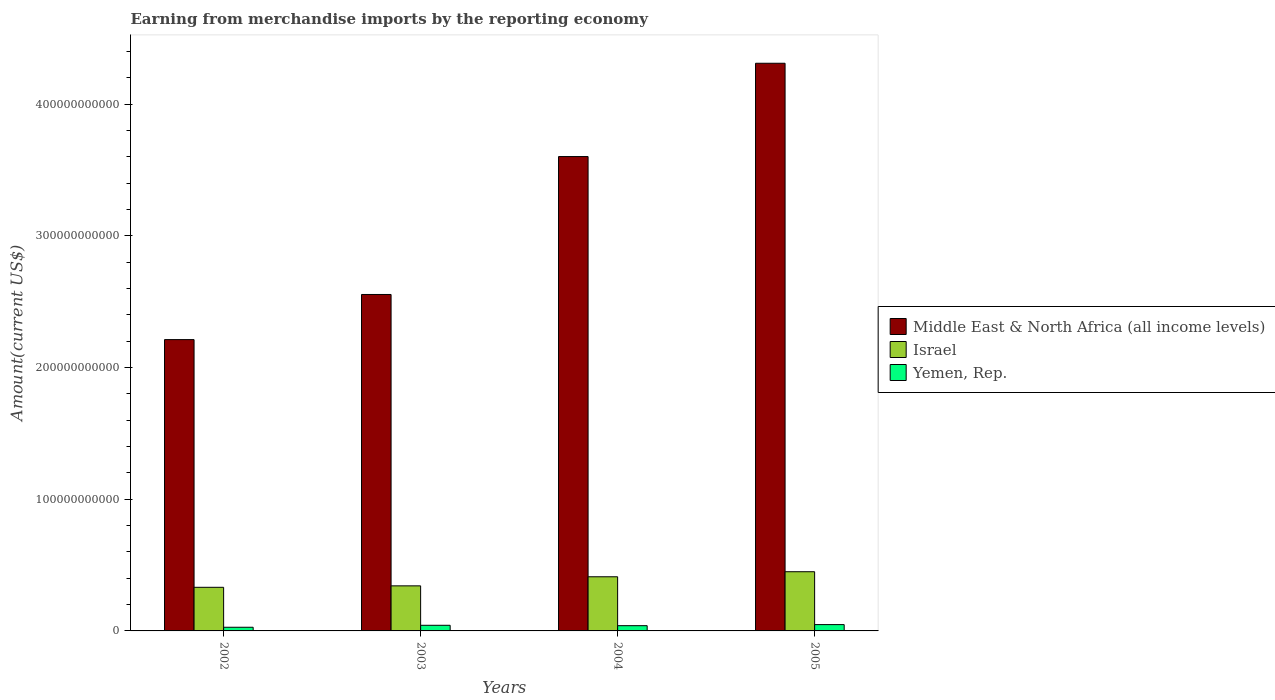Are the number of bars on each tick of the X-axis equal?
Ensure brevity in your answer.  Yes. How many bars are there on the 2nd tick from the left?
Provide a short and direct response. 3. What is the label of the 4th group of bars from the left?
Provide a short and direct response. 2005. What is the amount earned from merchandise imports in Middle East & North Africa (all income levels) in 2002?
Your answer should be very brief. 2.21e+11. Across all years, what is the maximum amount earned from merchandise imports in Middle East & North Africa (all income levels)?
Provide a short and direct response. 4.31e+11. Across all years, what is the minimum amount earned from merchandise imports in Middle East & North Africa (all income levels)?
Offer a terse response. 2.21e+11. In which year was the amount earned from merchandise imports in Israel maximum?
Make the answer very short. 2005. What is the total amount earned from merchandise imports in Israel in the graph?
Offer a terse response. 1.53e+11. What is the difference between the amount earned from merchandise imports in Middle East & North Africa (all income levels) in 2004 and that in 2005?
Provide a short and direct response. -7.08e+1. What is the difference between the amount earned from merchandise imports in Middle East & North Africa (all income levels) in 2005 and the amount earned from merchandise imports in Yemen, Rep. in 2002?
Offer a very short reply. 4.28e+11. What is the average amount earned from merchandise imports in Middle East & North Africa (all income levels) per year?
Keep it short and to the point. 3.17e+11. In the year 2002, what is the difference between the amount earned from merchandise imports in Yemen, Rep. and amount earned from merchandise imports in Middle East & North Africa (all income levels)?
Make the answer very short. -2.18e+11. In how many years, is the amount earned from merchandise imports in Israel greater than 80000000000 US$?
Your answer should be compact. 0. What is the ratio of the amount earned from merchandise imports in Middle East & North Africa (all income levels) in 2004 to that in 2005?
Your response must be concise. 0.84. Is the amount earned from merchandise imports in Yemen, Rep. in 2002 less than that in 2003?
Offer a terse response. Yes. What is the difference between the highest and the second highest amount earned from merchandise imports in Yemen, Rep.?
Give a very brief answer. 5.30e+08. What is the difference between the highest and the lowest amount earned from merchandise imports in Israel?
Provide a succinct answer. 1.18e+1. What does the 1st bar from the right in 2002 represents?
Make the answer very short. Yemen, Rep. How many years are there in the graph?
Give a very brief answer. 4. What is the difference between two consecutive major ticks on the Y-axis?
Offer a terse response. 1.00e+11. Are the values on the major ticks of Y-axis written in scientific E-notation?
Your answer should be very brief. No. Does the graph contain any zero values?
Your answer should be compact. No. Does the graph contain grids?
Offer a terse response. No. Where does the legend appear in the graph?
Ensure brevity in your answer.  Center right. How are the legend labels stacked?
Provide a short and direct response. Vertical. What is the title of the graph?
Your response must be concise. Earning from merchandise imports by the reporting economy. Does "Cote d'Ivoire" appear as one of the legend labels in the graph?
Offer a very short reply. No. What is the label or title of the Y-axis?
Make the answer very short. Amount(current US$). What is the Amount(current US$) in Middle East & North Africa (all income levels) in 2002?
Give a very brief answer. 2.21e+11. What is the Amount(current US$) in Israel in 2002?
Give a very brief answer. 3.31e+1. What is the Amount(current US$) of Yemen, Rep. in 2002?
Provide a succinct answer. 2.78e+09. What is the Amount(current US$) in Middle East & North Africa (all income levels) in 2003?
Give a very brief answer. 2.55e+11. What is the Amount(current US$) of Israel in 2003?
Offer a very short reply. 3.42e+1. What is the Amount(current US$) of Yemen, Rep. in 2003?
Give a very brief answer. 4.27e+09. What is the Amount(current US$) of Middle East & North Africa (all income levels) in 2004?
Your answer should be compact. 3.60e+11. What is the Amount(current US$) in Israel in 2004?
Your answer should be very brief. 4.11e+1. What is the Amount(current US$) in Yemen, Rep. in 2004?
Ensure brevity in your answer.  3.98e+09. What is the Amount(current US$) in Middle East & North Africa (all income levels) in 2005?
Offer a terse response. 4.31e+11. What is the Amount(current US$) in Israel in 2005?
Offer a terse response. 4.49e+1. What is the Amount(current US$) of Yemen, Rep. in 2005?
Your answer should be compact. 4.80e+09. Across all years, what is the maximum Amount(current US$) of Middle East & North Africa (all income levels)?
Ensure brevity in your answer.  4.31e+11. Across all years, what is the maximum Amount(current US$) in Israel?
Ensure brevity in your answer.  4.49e+1. Across all years, what is the maximum Amount(current US$) in Yemen, Rep.?
Provide a short and direct response. 4.80e+09. Across all years, what is the minimum Amount(current US$) of Middle East & North Africa (all income levels)?
Keep it short and to the point. 2.21e+11. Across all years, what is the minimum Amount(current US$) in Israel?
Your answer should be very brief. 3.31e+1. Across all years, what is the minimum Amount(current US$) in Yemen, Rep.?
Your response must be concise. 2.78e+09. What is the total Amount(current US$) in Middle East & North Africa (all income levels) in the graph?
Your answer should be very brief. 1.27e+12. What is the total Amount(current US$) of Israel in the graph?
Offer a very short reply. 1.53e+11. What is the total Amount(current US$) of Yemen, Rep. in the graph?
Make the answer very short. 1.58e+1. What is the difference between the Amount(current US$) of Middle East & North Africa (all income levels) in 2002 and that in 2003?
Give a very brief answer. -3.43e+1. What is the difference between the Amount(current US$) of Israel in 2002 and that in 2003?
Your answer should be compact. -1.11e+09. What is the difference between the Amount(current US$) of Yemen, Rep. in 2002 and that in 2003?
Ensure brevity in your answer.  -1.49e+09. What is the difference between the Amount(current US$) in Middle East & North Africa (all income levels) in 2002 and that in 2004?
Your response must be concise. -1.39e+11. What is the difference between the Amount(current US$) in Israel in 2002 and that in 2004?
Keep it short and to the point. -7.99e+09. What is the difference between the Amount(current US$) in Yemen, Rep. in 2002 and that in 2004?
Give a very brief answer. -1.21e+09. What is the difference between the Amount(current US$) in Middle East & North Africa (all income levels) in 2002 and that in 2005?
Ensure brevity in your answer.  -2.10e+11. What is the difference between the Amount(current US$) of Israel in 2002 and that in 2005?
Your answer should be compact. -1.18e+1. What is the difference between the Amount(current US$) in Yemen, Rep. in 2002 and that in 2005?
Your response must be concise. -2.02e+09. What is the difference between the Amount(current US$) in Middle East & North Africa (all income levels) in 2003 and that in 2004?
Your answer should be very brief. -1.05e+11. What is the difference between the Amount(current US$) in Israel in 2003 and that in 2004?
Your response must be concise. -6.89e+09. What is the difference between the Amount(current US$) of Yemen, Rep. in 2003 and that in 2004?
Keep it short and to the point. 2.85e+08. What is the difference between the Amount(current US$) in Middle East & North Africa (all income levels) in 2003 and that in 2005?
Your answer should be compact. -1.76e+11. What is the difference between the Amount(current US$) of Israel in 2003 and that in 2005?
Your response must be concise. -1.07e+1. What is the difference between the Amount(current US$) in Yemen, Rep. in 2003 and that in 2005?
Give a very brief answer. -5.30e+08. What is the difference between the Amount(current US$) in Middle East & North Africa (all income levels) in 2004 and that in 2005?
Your answer should be very brief. -7.08e+1. What is the difference between the Amount(current US$) in Israel in 2004 and that in 2005?
Your answer should be very brief. -3.84e+09. What is the difference between the Amount(current US$) of Yemen, Rep. in 2004 and that in 2005?
Make the answer very short. -8.15e+08. What is the difference between the Amount(current US$) in Middle East & North Africa (all income levels) in 2002 and the Amount(current US$) in Israel in 2003?
Your response must be concise. 1.87e+11. What is the difference between the Amount(current US$) of Middle East & North Africa (all income levels) in 2002 and the Amount(current US$) of Yemen, Rep. in 2003?
Give a very brief answer. 2.17e+11. What is the difference between the Amount(current US$) in Israel in 2002 and the Amount(current US$) in Yemen, Rep. in 2003?
Give a very brief answer. 2.88e+1. What is the difference between the Amount(current US$) in Middle East & North Africa (all income levels) in 2002 and the Amount(current US$) in Israel in 2004?
Offer a terse response. 1.80e+11. What is the difference between the Amount(current US$) in Middle East & North Africa (all income levels) in 2002 and the Amount(current US$) in Yemen, Rep. in 2004?
Your answer should be compact. 2.17e+11. What is the difference between the Amount(current US$) in Israel in 2002 and the Amount(current US$) in Yemen, Rep. in 2004?
Offer a very short reply. 2.91e+1. What is the difference between the Amount(current US$) in Middle East & North Africa (all income levels) in 2002 and the Amount(current US$) in Israel in 2005?
Ensure brevity in your answer.  1.76e+11. What is the difference between the Amount(current US$) of Middle East & North Africa (all income levels) in 2002 and the Amount(current US$) of Yemen, Rep. in 2005?
Provide a succinct answer. 2.16e+11. What is the difference between the Amount(current US$) in Israel in 2002 and the Amount(current US$) in Yemen, Rep. in 2005?
Your response must be concise. 2.83e+1. What is the difference between the Amount(current US$) in Middle East & North Africa (all income levels) in 2003 and the Amount(current US$) in Israel in 2004?
Ensure brevity in your answer.  2.14e+11. What is the difference between the Amount(current US$) of Middle East & North Africa (all income levels) in 2003 and the Amount(current US$) of Yemen, Rep. in 2004?
Your answer should be very brief. 2.51e+11. What is the difference between the Amount(current US$) in Israel in 2003 and the Amount(current US$) in Yemen, Rep. in 2004?
Your answer should be very brief. 3.02e+1. What is the difference between the Amount(current US$) of Middle East & North Africa (all income levels) in 2003 and the Amount(current US$) of Israel in 2005?
Provide a short and direct response. 2.10e+11. What is the difference between the Amount(current US$) of Middle East & North Africa (all income levels) in 2003 and the Amount(current US$) of Yemen, Rep. in 2005?
Your answer should be very brief. 2.51e+11. What is the difference between the Amount(current US$) in Israel in 2003 and the Amount(current US$) in Yemen, Rep. in 2005?
Offer a very short reply. 2.94e+1. What is the difference between the Amount(current US$) of Middle East & North Africa (all income levels) in 2004 and the Amount(current US$) of Israel in 2005?
Provide a succinct answer. 3.15e+11. What is the difference between the Amount(current US$) in Middle East & North Africa (all income levels) in 2004 and the Amount(current US$) in Yemen, Rep. in 2005?
Your answer should be very brief. 3.55e+11. What is the difference between the Amount(current US$) in Israel in 2004 and the Amount(current US$) in Yemen, Rep. in 2005?
Provide a succinct answer. 3.63e+1. What is the average Amount(current US$) in Middle East & North Africa (all income levels) per year?
Give a very brief answer. 3.17e+11. What is the average Amount(current US$) in Israel per year?
Your answer should be very brief. 3.83e+1. What is the average Amount(current US$) of Yemen, Rep. per year?
Offer a terse response. 3.96e+09. In the year 2002, what is the difference between the Amount(current US$) of Middle East & North Africa (all income levels) and Amount(current US$) of Israel?
Provide a succinct answer. 1.88e+11. In the year 2002, what is the difference between the Amount(current US$) of Middle East & North Africa (all income levels) and Amount(current US$) of Yemen, Rep.?
Make the answer very short. 2.18e+11. In the year 2002, what is the difference between the Amount(current US$) in Israel and Amount(current US$) in Yemen, Rep.?
Provide a succinct answer. 3.03e+1. In the year 2003, what is the difference between the Amount(current US$) in Middle East & North Africa (all income levels) and Amount(current US$) in Israel?
Keep it short and to the point. 2.21e+11. In the year 2003, what is the difference between the Amount(current US$) of Middle East & North Africa (all income levels) and Amount(current US$) of Yemen, Rep.?
Ensure brevity in your answer.  2.51e+11. In the year 2003, what is the difference between the Amount(current US$) of Israel and Amount(current US$) of Yemen, Rep.?
Ensure brevity in your answer.  2.99e+1. In the year 2004, what is the difference between the Amount(current US$) in Middle East & North Africa (all income levels) and Amount(current US$) in Israel?
Make the answer very short. 3.19e+11. In the year 2004, what is the difference between the Amount(current US$) in Middle East & North Africa (all income levels) and Amount(current US$) in Yemen, Rep.?
Offer a terse response. 3.56e+11. In the year 2004, what is the difference between the Amount(current US$) of Israel and Amount(current US$) of Yemen, Rep.?
Offer a terse response. 3.71e+1. In the year 2005, what is the difference between the Amount(current US$) in Middle East & North Africa (all income levels) and Amount(current US$) in Israel?
Offer a very short reply. 3.86e+11. In the year 2005, what is the difference between the Amount(current US$) of Middle East & North Africa (all income levels) and Amount(current US$) of Yemen, Rep.?
Make the answer very short. 4.26e+11. In the year 2005, what is the difference between the Amount(current US$) of Israel and Amount(current US$) of Yemen, Rep.?
Make the answer very short. 4.01e+1. What is the ratio of the Amount(current US$) in Middle East & North Africa (all income levels) in 2002 to that in 2003?
Your response must be concise. 0.87. What is the ratio of the Amount(current US$) of Israel in 2002 to that in 2003?
Offer a terse response. 0.97. What is the ratio of the Amount(current US$) in Yemen, Rep. in 2002 to that in 2003?
Provide a succinct answer. 0.65. What is the ratio of the Amount(current US$) in Middle East & North Africa (all income levels) in 2002 to that in 2004?
Provide a succinct answer. 0.61. What is the ratio of the Amount(current US$) in Israel in 2002 to that in 2004?
Ensure brevity in your answer.  0.81. What is the ratio of the Amount(current US$) in Yemen, Rep. in 2002 to that in 2004?
Make the answer very short. 0.7. What is the ratio of the Amount(current US$) in Middle East & North Africa (all income levels) in 2002 to that in 2005?
Ensure brevity in your answer.  0.51. What is the ratio of the Amount(current US$) of Israel in 2002 to that in 2005?
Make the answer very short. 0.74. What is the ratio of the Amount(current US$) of Yemen, Rep. in 2002 to that in 2005?
Your answer should be very brief. 0.58. What is the ratio of the Amount(current US$) of Middle East & North Africa (all income levels) in 2003 to that in 2004?
Your answer should be compact. 0.71. What is the ratio of the Amount(current US$) in Israel in 2003 to that in 2004?
Your response must be concise. 0.83. What is the ratio of the Amount(current US$) of Yemen, Rep. in 2003 to that in 2004?
Offer a very short reply. 1.07. What is the ratio of the Amount(current US$) of Middle East & North Africa (all income levels) in 2003 to that in 2005?
Your answer should be compact. 0.59. What is the ratio of the Amount(current US$) in Israel in 2003 to that in 2005?
Make the answer very short. 0.76. What is the ratio of the Amount(current US$) in Yemen, Rep. in 2003 to that in 2005?
Give a very brief answer. 0.89. What is the ratio of the Amount(current US$) of Middle East & North Africa (all income levels) in 2004 to that in 2005?
Provide a short and direct response. 0.84. What is the ratio of the Amount(current US$) of Israel in 2004 to that in 2005?
Provide a short and direct response. 0.91. What is the ratio of the Amount(current US$) in Yemen, Rep. in 2004 to that in 2005?
Offer a terse response. 0.83. What is the difference between the highest and the second highest Amount(current US$) in Middle East & North Africa (all income levels)?
Offer a terse response. 7.08e+1. What is the difference between the highest and the second highest Amount(current US$) of Israel?
Provide a short and direct response. 3.84e+09. What is the difference between the highest and the second highest Amount(current US$) of Yemen, Rep.?
Your response must be concise. 5.30e+08. What is the difference between the highest and the lowest Amount(current US$) in Middle East & North Africa (all income levels)?
Your answer should be compact. 2.10e+11. What is the difference between the highest and the lowest Amount(current US$) of Israel?
Provide a short and direct response. 1.18e+1. What is the difference between the highest and the lowest Amount(current US$) in Yemen, Rep.?
Your answer should be very brief. 2.02e+09. 